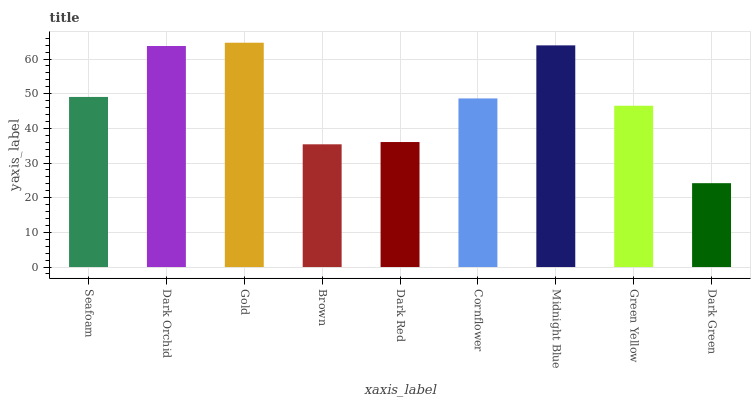Is Dark Green the minimum?
Answer yes or no. Yes. Is Gold the maximum?
Answer yes or no. Yes. Is Dark Orchid the minimum?
Answer yes or no. No. Is Dark Orchid the maximum?
Answer yes or no. No. Is Dark Orchid greater than Seafoam?
Answer yes or no. Yes. Is Seafoam less than Dark Orchid?
Answer yes or no. Yes. Is Seafoam greater than Dark Orchid?
Answer yes or no. No. Is Dark Orchid less than Seafoam?
Answer yes or no. No. Is Cornflower the high median?
Answer yes or no. Yes. Is Cornflower the low median?
Answer yes or no. Yes. Is Gold the high median?
Answer yes or no. No. Is Dark Red the low median?
Answer yes or no. No. 